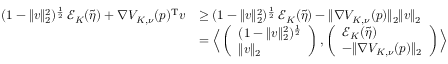<formula> <loc_0><loc_0><loc_500><loc_500>\begin{array} { r l } { ( 1 - \| v \| _ { 2 } ^ { 2 } ) ^ { \frac { 1 } { 2 } } \, \mathcal { E } _ { K } ( \tilde { \eta } ) + \nabla V _ { K , \nu } ( p ) ^ { T } v } & { \geq ( 1 - \| v \| _ { 2 } ^ { 2 } ) ^ { \frac { 1 } { 2 } } \, \mathcal { E } _ { K } ( \tilde { \eta } ) - \| \nabla V _ { K , \nu } ( p ) \| _ { 2 } \| v \| _ { 2 } } \\ & { = \left \langle \left ( \begin{array} { l } { ( 1 - \| v \| _ { 2 } ^ { 2 } ) ^ { \frac { 1 } { 2 } } } \\ { \| v \| _ { 2 } } \end{array} \right ) , \left ( \begin{array} { l } { \mathcal { E } _ { K } ( \tilde { \eta } ) } \\ { - \| \nabla V _ { K , \nu } ( p ) \| _ { 2 } } \end{array} \right ) \right \rangle } \end{array}</formula> 